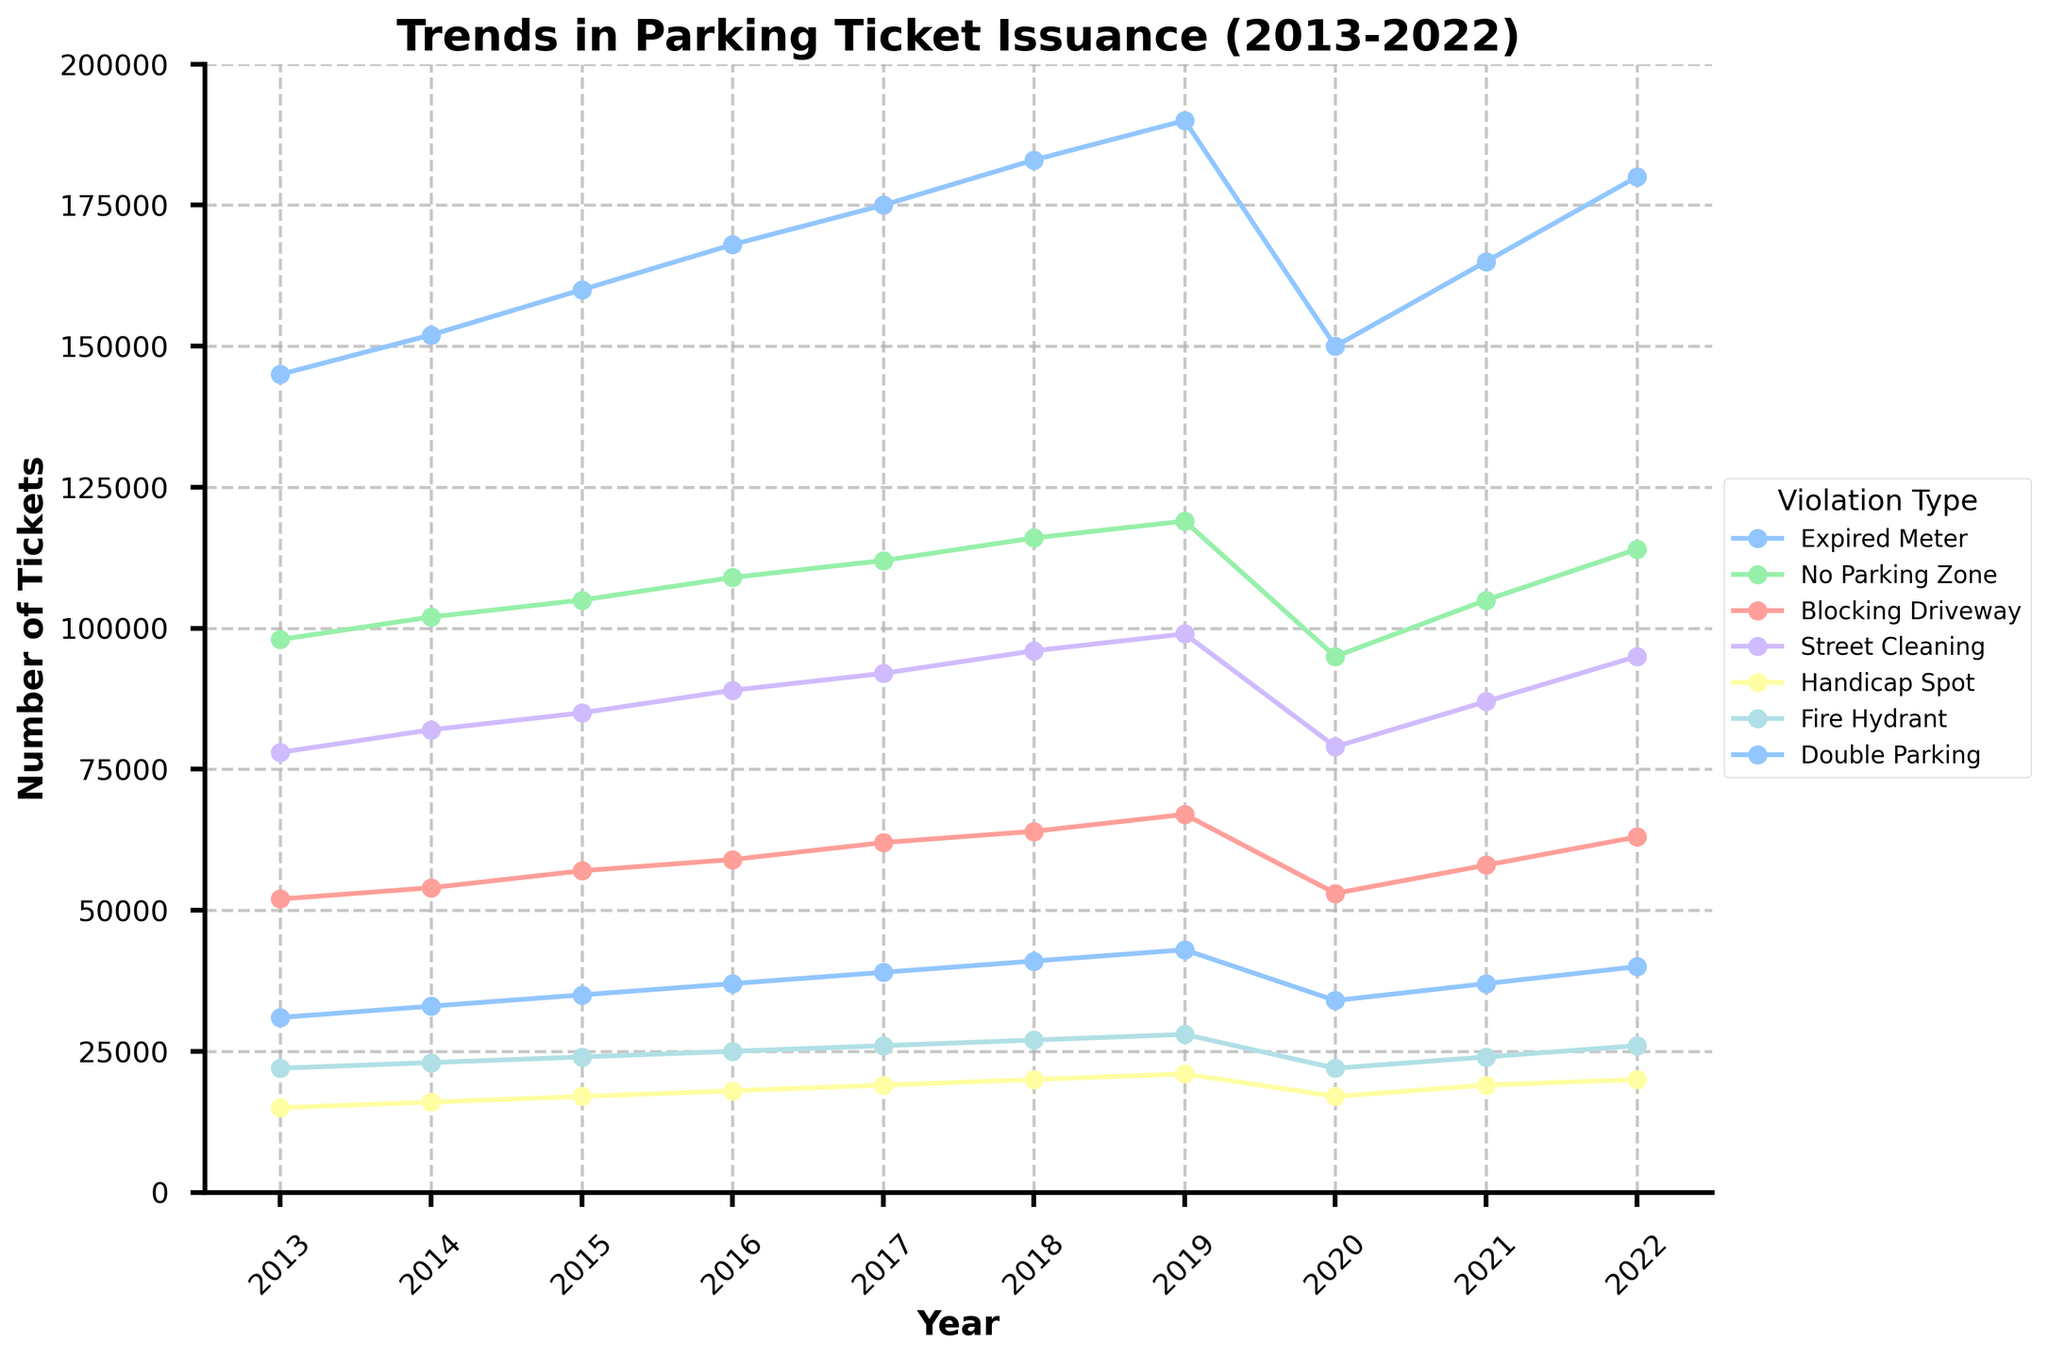Which violation type saw the highest number of tickets issued in 2017? By looking at the figure, find the year 2017 on the x-axis and identify the violation type with the tallest line marker.
Answer: Expired Meter How did the number of tickets for Street Cleaning change from 2020 to 2021? Observe the line representing Street Cleaning and compare the values at the years 2020 and 2021. Subtract the 2020 value from the 2021 value.
Answer: Increased by 8,000 Which violation type experienced a decrease in the number of tickets issued in 2020 compared to 2019? For each violation type, compare the values between 2019 and 2020. Identify which one had a lower value in 2020 than in 2019.
Answer: All types What's the average number of tickets issued for Blocking Driveway from 2013 to 2015? Sum the number of tickets issued for Blocking Driveway from 2013 to 2015 and divide by the number of years. (52000 + 54000 + 57000) / 3
Answer: 54,000 Which year had the lowest number of tickets for Handicap Spot? Identify the lowest point on the line representing Handicap Spot and note the corresponding year.
Answer: 2013 Between 2016 and 2018, which violation type saw the greatest increase in the number of tickets issued? Calculate the difference in the number of tickets between 2016 and 2018 for each violation type and identify the maximum increase.
Answer: Expired Meter Compare the number of tickets for Double Parking in 2013 and 2022. Is there an increase or decrease, and by how much? Subtract the 2013 value for Double Parking from the 2022 value.
Answer: Increased by 9,000 What's the sum of tickets issued for Expired Meter and No Parking Zone in 2015? Add the number of tickets for Expired Meter and No Parking Zone in 2015. (160000 + 105000)
Answer: 265,000 How does the trend for tickets issued for Fire Hydrant compare to Street Cleaning from 2013 to 2022? Observe the two lines for Fire Hydrant and Street Cleaning, and compare their general trends over the given years.
Answer: Both trends increase but Street Cleaning sees larger fluctuations What is the difference in the number of tickets issued for Expired Meter between 2019 and 2020? Subtract the 2020 value for Expired Meter from the 2019 value.
Answer: Decreased by 40,000 